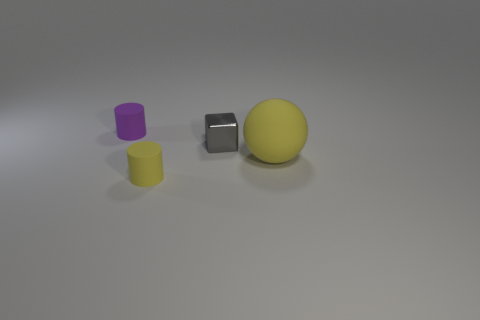Add 3 yellow matte cylinders. How many objects exist? 7 Subtract all balls. How many objects are left? 3 Add 3 large matte objects. How many large matte objects are left? 4 Add 4 yellow matte balls. How many yellow matte balls exist? 5 Subtract 0 purple blocks. How many objects are left? 4 Subtract all tiny purple things. Subtract all gray blocks. How many objects are left? 2 